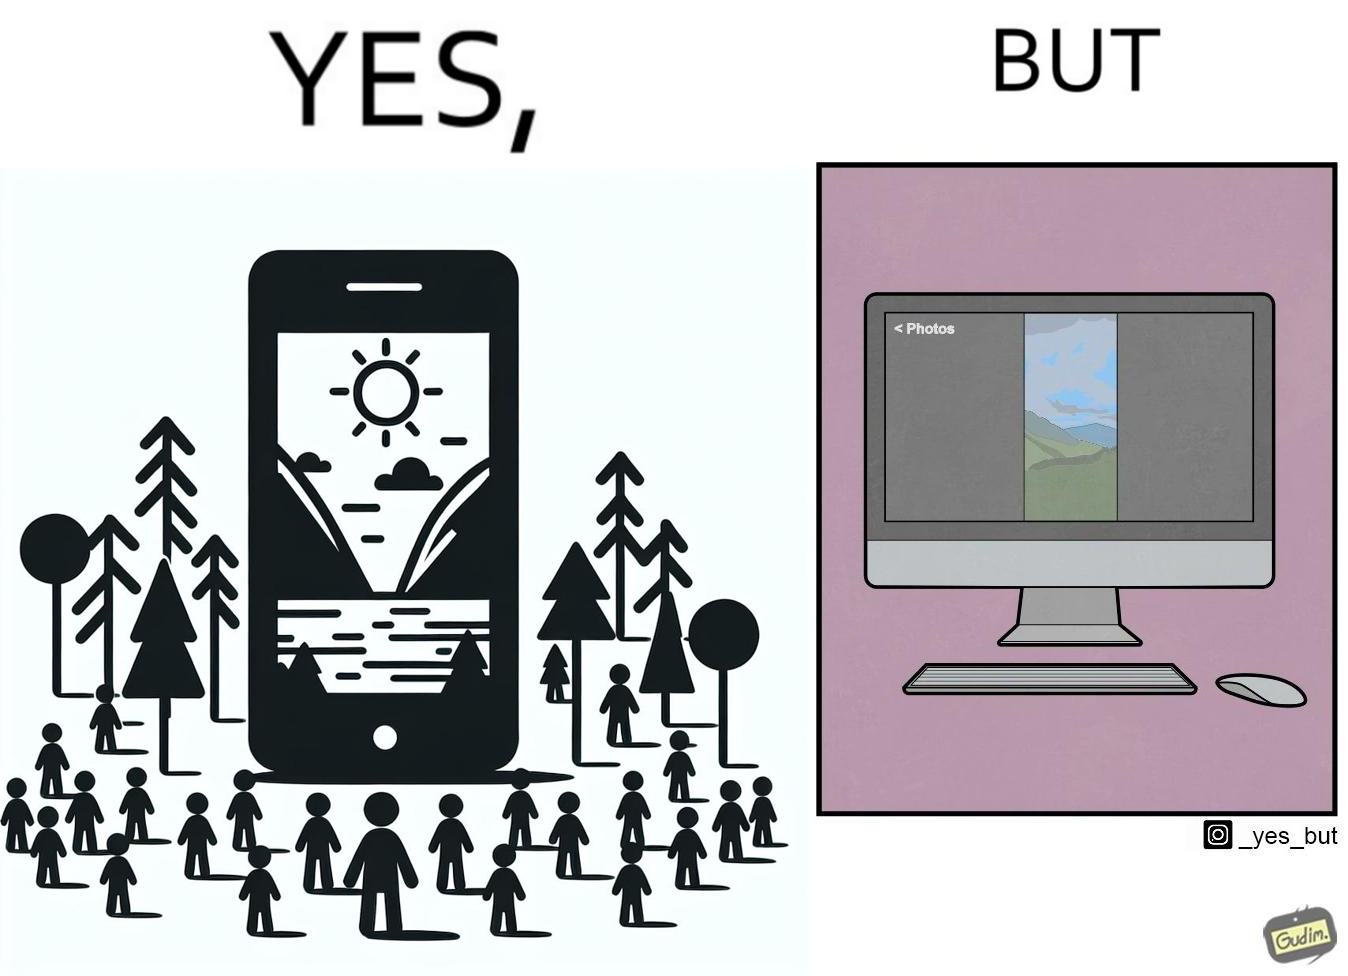Describe the contrast between the left and right parts of this image. In the left part of the image: an image of a scenic view on mobile In the right part of the image: an image of a scenic view in portrait mode on a computer monitor. 